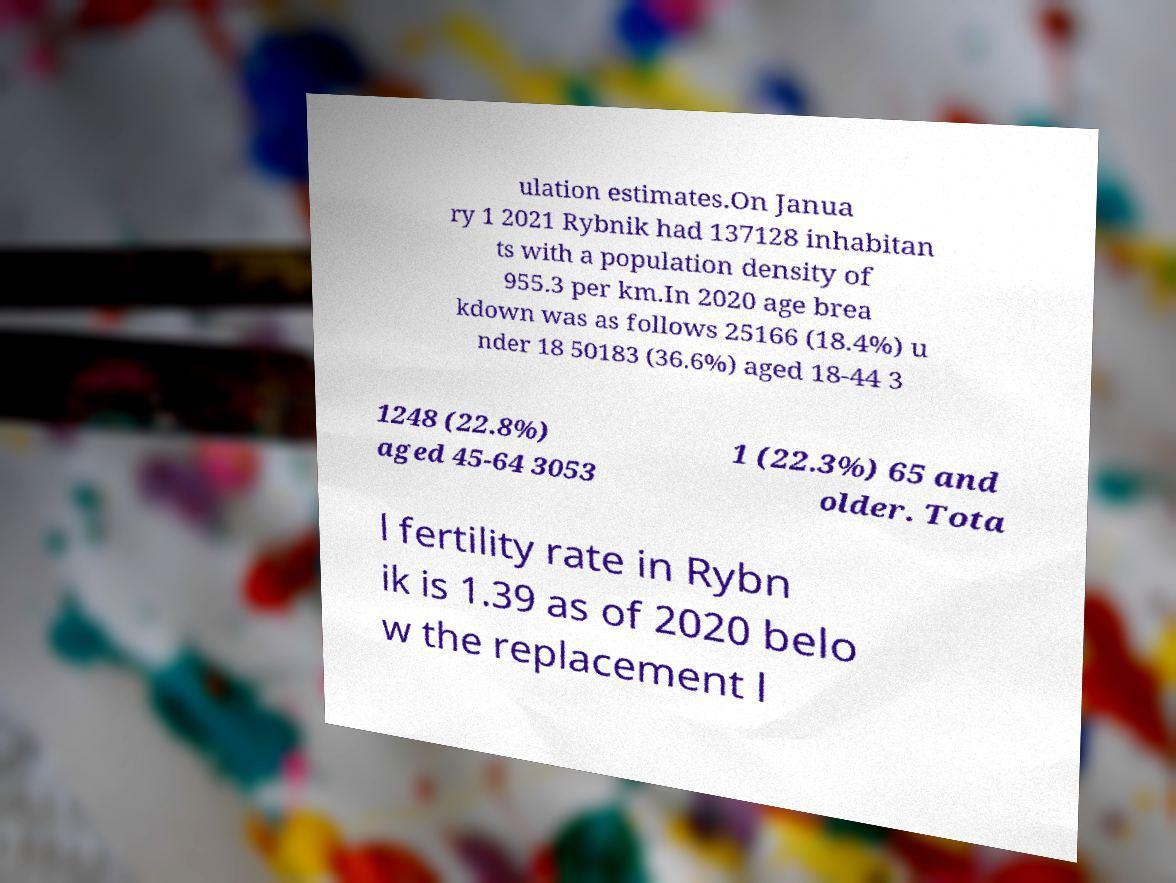Could you extract and type out the text from this image? ulation estimates.On Janua ry 1 2021 Rybnik had 137128 inhabitan ts with a population density of 955.3 per km.In 2020 age brea kdown was as follows 25166 (18.4%) u nder 18 50183 (36.6%) aged 18-44 3 1248 (22.8%) aged 45-64 3053 1 (22.3%) 65 and older. Tota l fertility rate in Rybn ik is 1.39 as of 2020 belo w the replacement l 